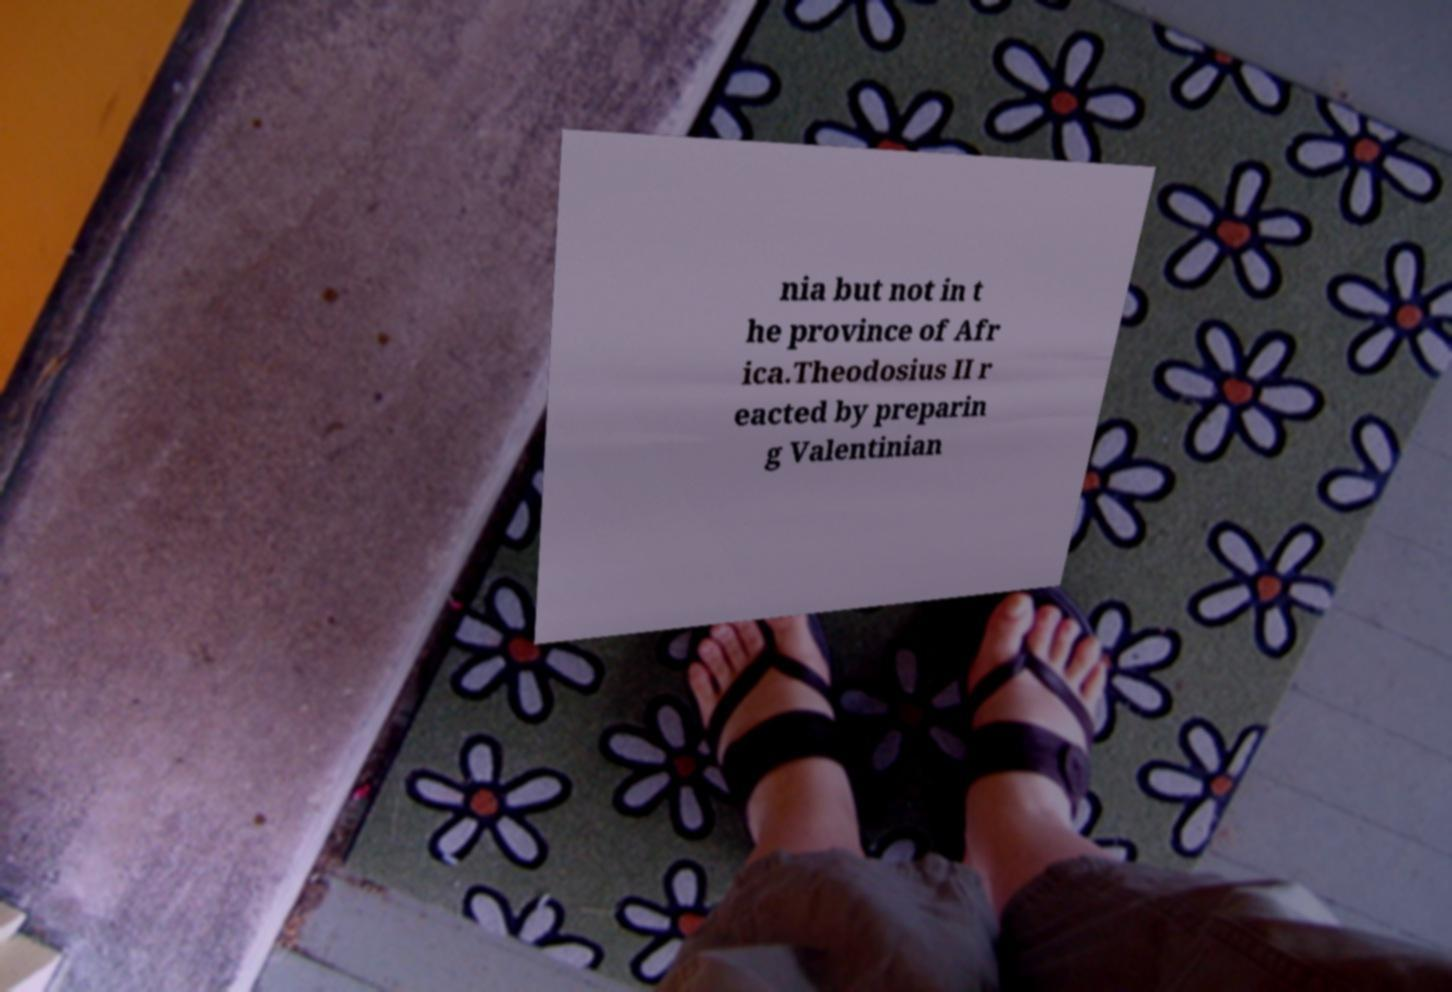Could you assist in decoding the text presented in this image and type it out clearly? nia but not in t he province of Afr ica.Theodosius II r eacted by preparin g Valentinian 